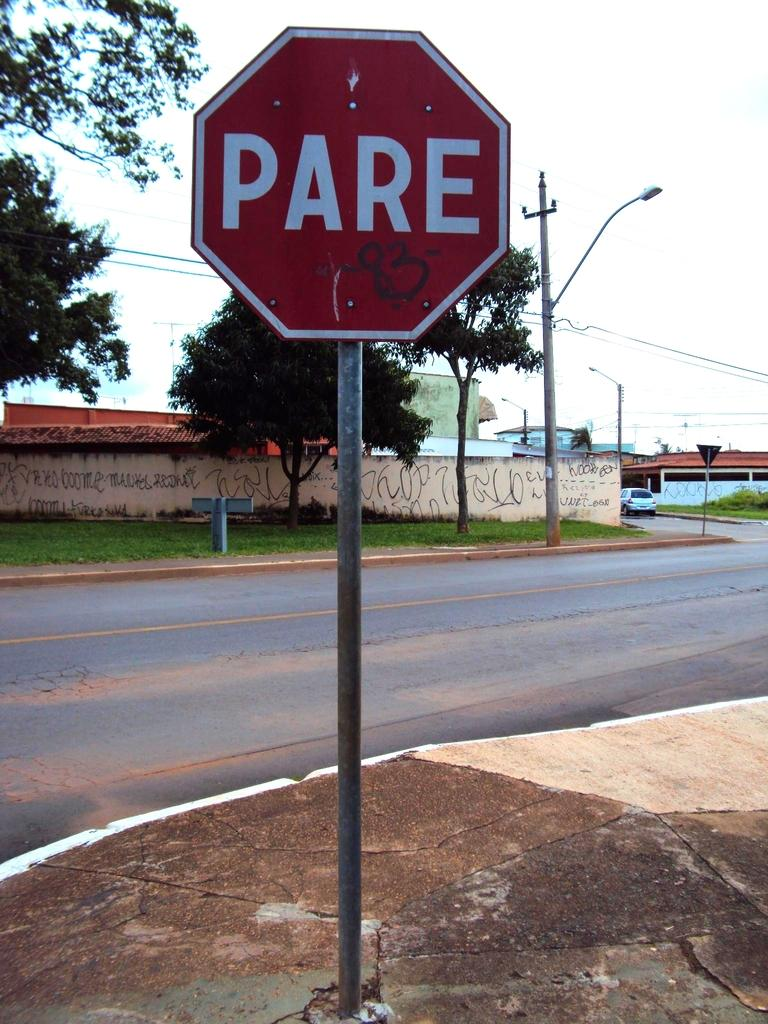<image>
Render a clear and concise summary of the photo. a sign with the word Pare on it 